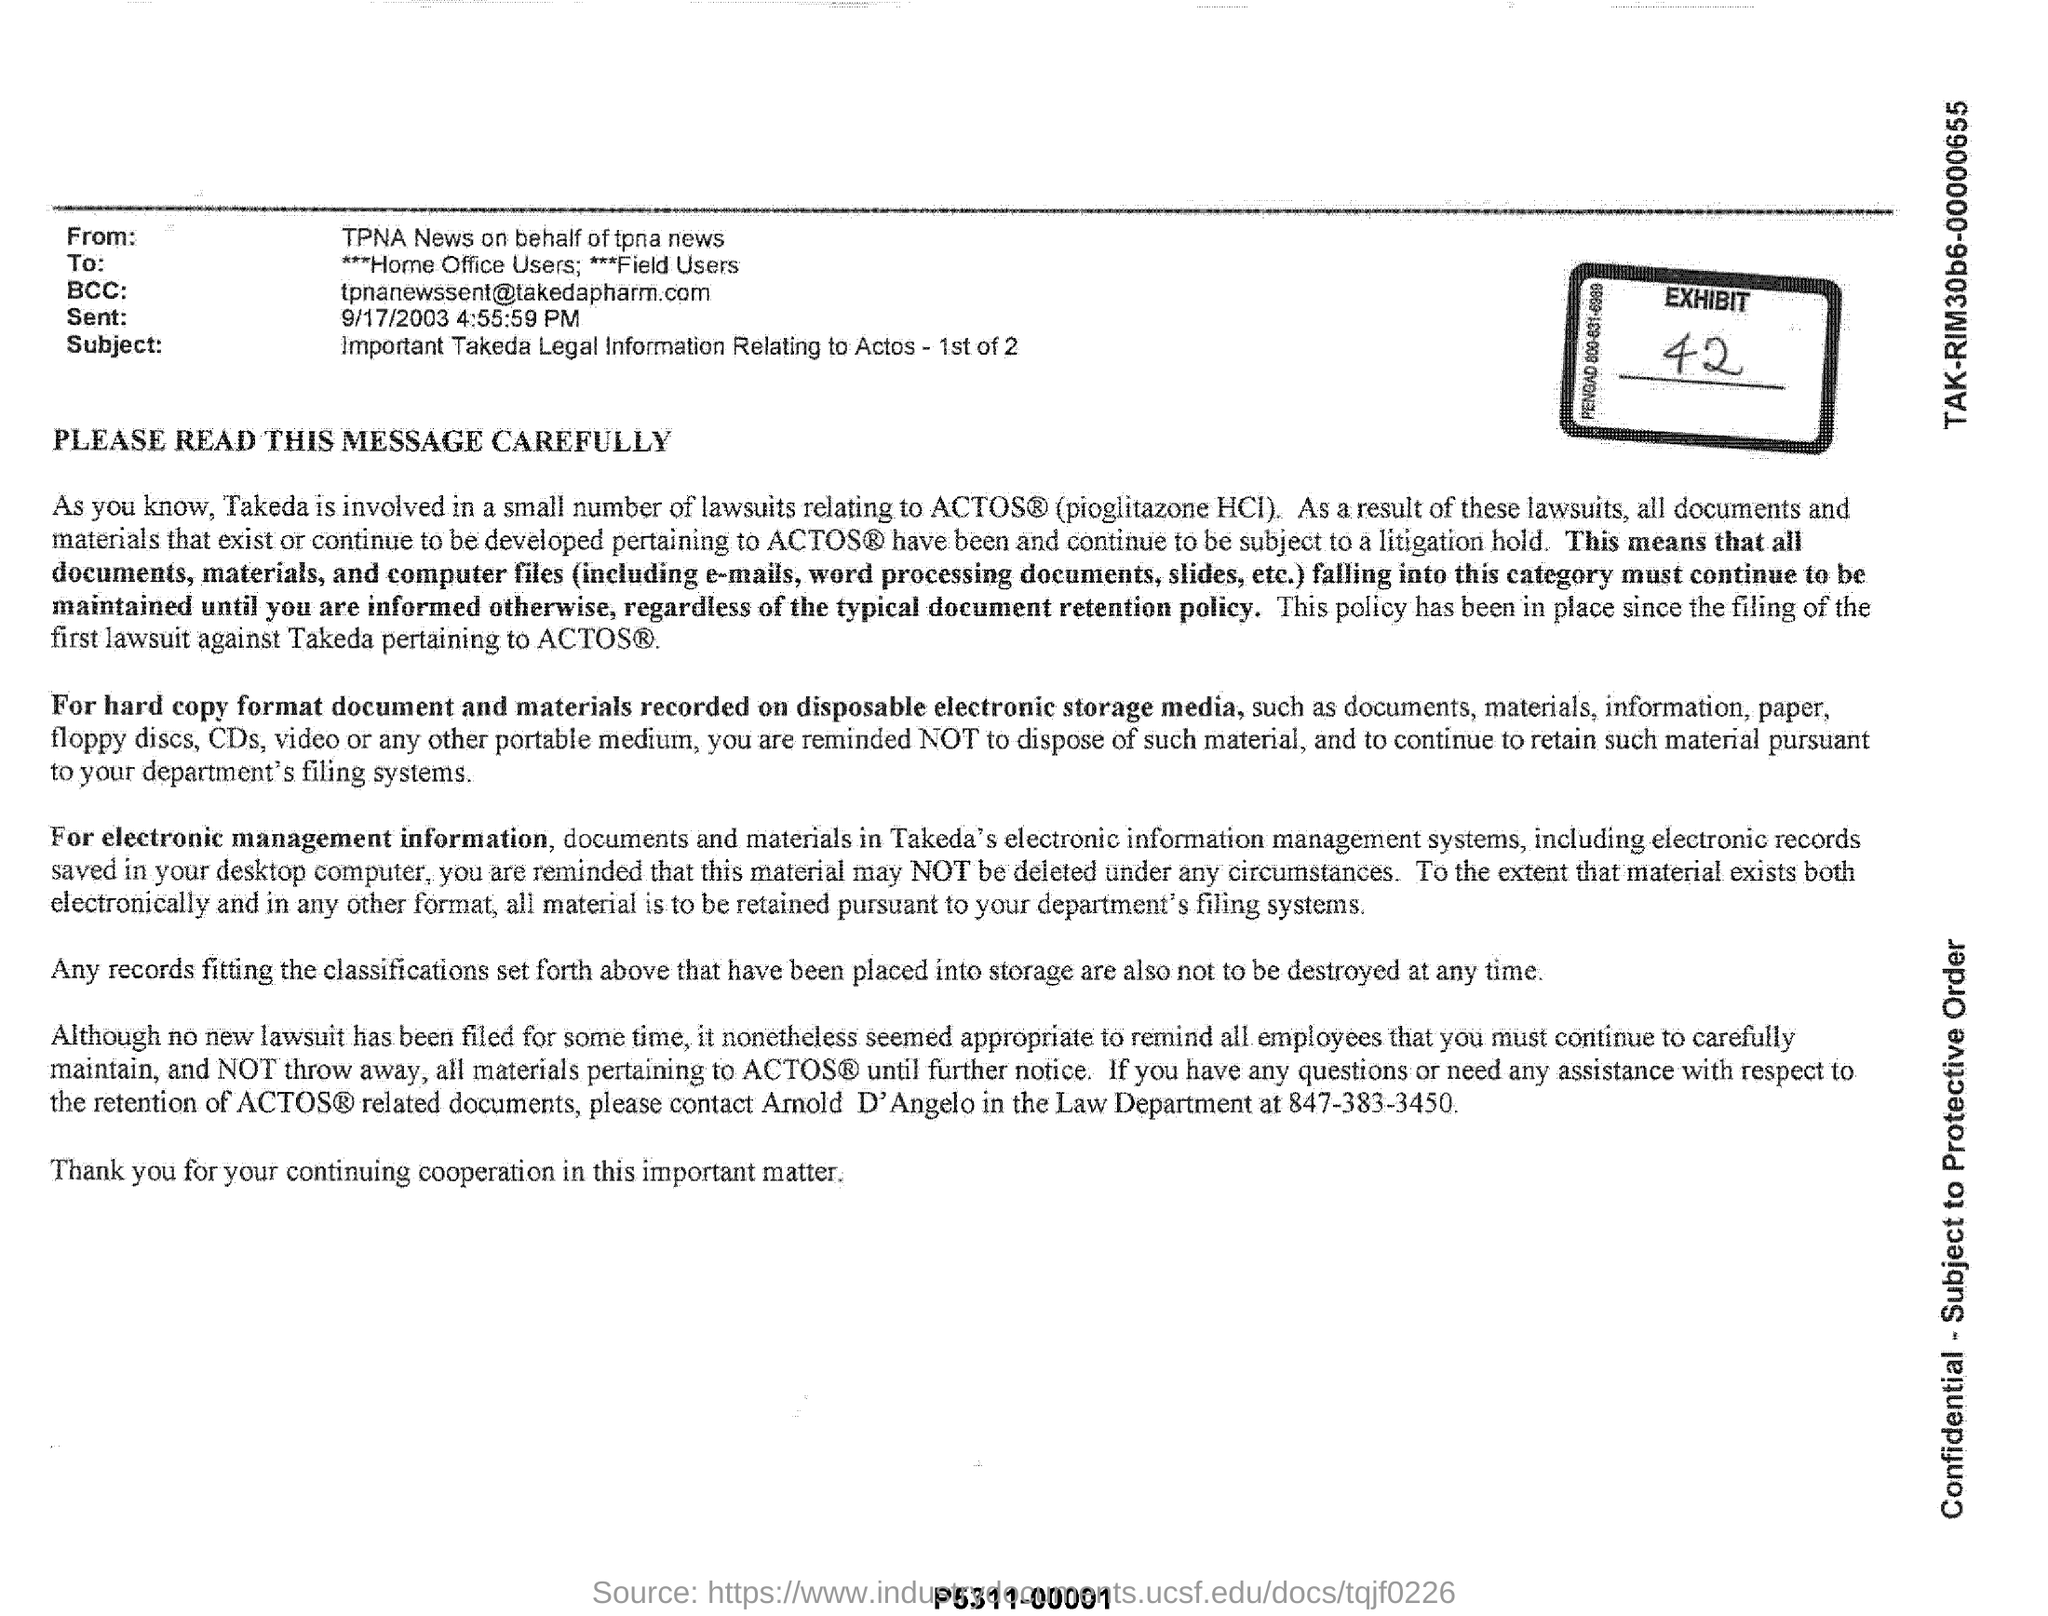From whom is this document
Keep it short and to the point. TPNA News on behalf of tpna news. Who is the sender of this email?
Keep it short and to the point. TPNA News on behalf of tpna news. What is the subject of this email?
Keep it short and to the point. Important Takeda Legal Information Relating to Actos - 1st of 2. 